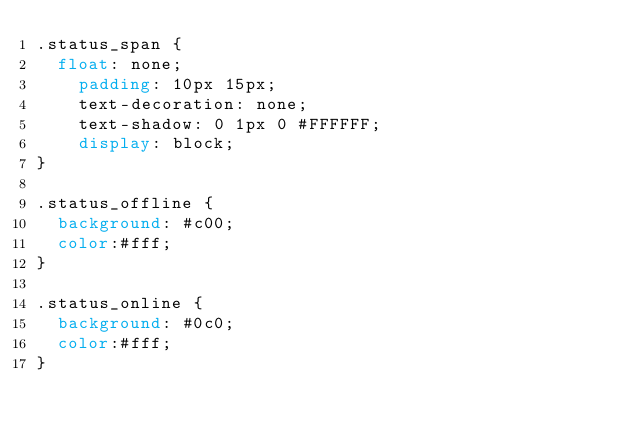<code> <loc_0><loc_0><loc_500><loc_500><_CSS_>.status_span {
	float: none;
    padding: 10px 15px;
    text-decoration: none;
    text-shadow: 0 1px 0 #FFFFFF;
    display: block;
}

.status_offline {
  background: #c00;
  color:#fff;
}

.status_online {
  background: #0c0;
  color:#fff;
}
</code> 